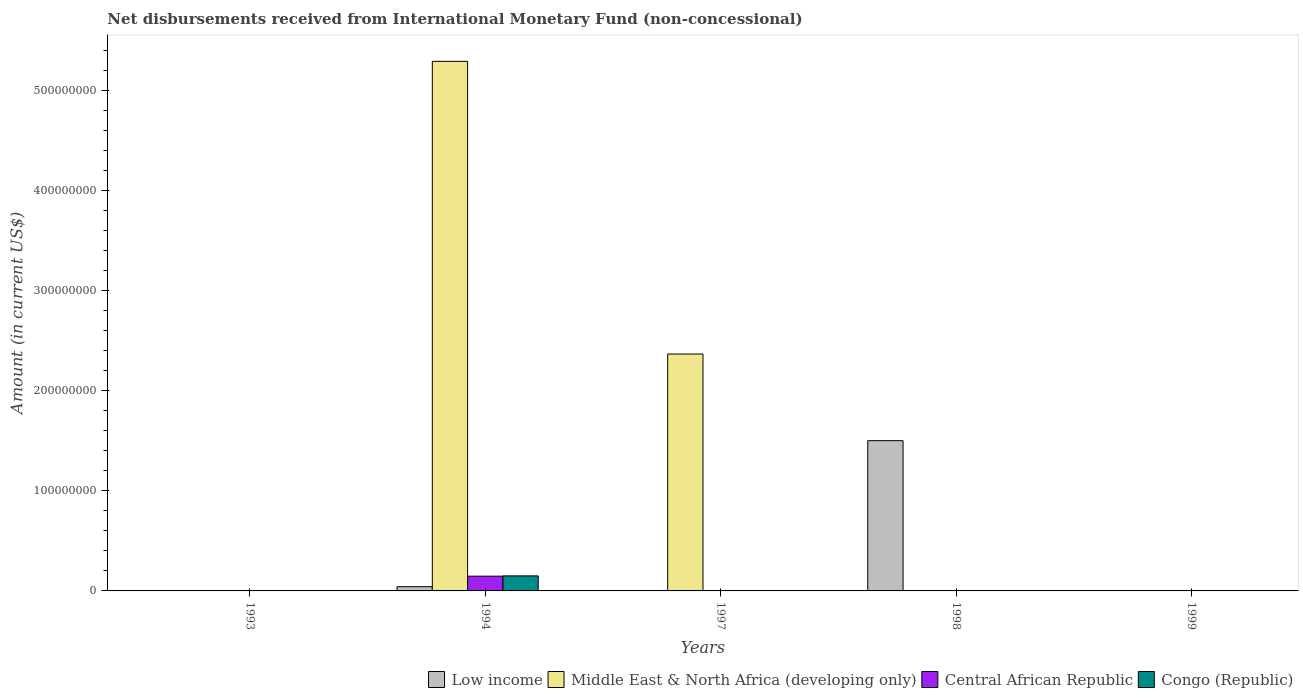How many different coloured bars are there?
Provide a short and direct response. 4. Are the number of bars on each tick of the X-axis equal?
Ensure brevity in your answer.  No. How many bars are there on the 4th tick from the right?
Keep it short and to the point. 4. What is the label of the 3rd group of bars from the left?
Make the answer very short. 1997. Across all years, what is the maximum amount of disbursements received from International Monetary Fund in Central African Republic?
Make the answer very short. 1.48e+07. Across all years, what is the minimum amount of disbursements received from International Monetary Fund in Central African Republic?
Ensure brevity in your answer.  0. What is the total amount of disbursements received from International Monetary Fund in Central African Republic in the graph?
Provide a succinct answer. 1.48e+07. What is the difference between the amount of disbursements received from International Monetary Fund in Middle East & North Africa (developing only) in 1994 and that in 1997?
Keep it short and to the point. 2.93e+08. What is the difference between the amount of disbursements received from International Monetary Fund in Congo (Republic) in 1999 and the amount of disbursements received from International Monetary Fund in Central African Republic in 1994?
Your response must be concise. -1.48e+07. What is the average amount of disbursements received from International Monetary Fund in Central African Republic per year?
Offer a terse response. 2.95e+06. In the year 1994, what is the difference between the amount of disbursements received from International Monetary Fund in Central African Republic and amount of disbursements received from International Monetary Fund in Congo (Republic)?
Offer a very short reply. -2.81e+05. In how many years, is the amount of disbursements received from International Monetary Fund in Central African Republic greater than 200000000 US$?
Your answer should be compact. 0. What is the difference between the highest and the lowest amount of disbursements received from International Monetary Fund in Low income?
Your answer should be very brief. 1.50e+08. Is it the case that in every year, the sum of the amount of disbursements received from International Monetary Fund in Low income and amount of disbursements received from International Monetary Fund in Congo (Republic) is greater than the sum of amount of disbursements received from International Monetary Fund in Central African Republic and amount of disbursements received from International Monetary Fund in Middle East & North Africa (developing only)?
Ensure brevity in your answer.  No. How many bars are there?
Ensure brevity in your answer.  6. Are all the bars in the graph horizontal?
Your answer should be very brief. No. How many years are there in the graph?
Ensure brevity in your answer.  5. What is the difference between two consecutive major ticks on the Y-axis?
Keep it short and to the point. 1.00e+08. Are the values on the major ticks of Y-axis written in scientific E-notation?
Keep it short and to the point. No. Does the graph contain any zero values?
Provide a succinct answer. Yes. Does the graph contain grids?
Make the answer very short. No. What is the title of the graph?
Keep it short and to the point. Net disbursements received from International Monetary Fund (non-concessional). What is the Amount (in current US$) of Low income in 1993?
Your answer should be compact. 0. What is the Amount (in current US$) of Central African Republic in 1993?
Provide a short and direct response. 0. What is the Amount (in current US$) of Low income in 1994?
Make the answer very short. 4.24e+06. What is the Amount (in current US$) in Middle East & North Africa (developing only) in 1994?
Your answer should be compact. 5.29e+08. What is the Amount (in current US$) of Central African Republic in 1994?
Your answer should be compact. 1.48e+07. What is the Amount (in current US$) in Congo (Republic) in 1994?
Offer a terse response. 1.50e+07. What is the Amount (in current US$) of Middle East & North Africa (developing only) in 1997?
Make the answer very short. 2.37e+08. What is the Amount (in current US$) in Central African Republic in 1997?
Your answer should be compact. 0. What is the Amount (in current US$) of Low income in 1998?
Provide a short and direct response. 1.50e+08. What is the Amount (in current US$) in Middle East & North Africa (developing only) in 1998?
Keep it short and to the point. 0. What is the Amount (in current US$) in Middle East & North Africa (developing only) in 1999?
Your answer should be compact. 0. What is the Amount (in current US$) of Central African Republic in 1999?
Your answer should be very brief. 0. What is the Amount (in current US$) of Congo (Republic) in 1999?
Provide a short and direct response. 0. Across all years, what is the maximum Amount (in current US$) of Low income?
Offer a very short reply. 1.50e+08. Across all years, what is the maximum Amount (in current US$) in Middle East & North Africa (developing only)?
Keep it short and to the point. 5.29e+08. Across all years, what is the maximum Amount (in current US$) of Central African Republic?
Keep it short and to the point. 1.48e+07. Across all years, what is the maximum Amount (in current US$) in Congo (Republic)?
Offer a very short reply. 1.50e+07. Across all years, what is the minimum Amount (in current US$) of Central African Republic?
Ensure brevity in your answer.  0. Across all years, what is the minimum Amount (in current US$) in Congo (Republic)?
Give a very brief answer. 0. What is the total Amount (in current US$) in Low income in the graph?
Offer a terse response. 1.54e+08. What is the total Amount (in current US$) in Middle East & North Africa (developing only) in the graph?
Your answer should be compact. 7.66e+08. What is the total Amount (in current US$) of Central African Republic in the graph?
Offer a very short reply. 1.48e+07. What is the total Amount (in current US$) in Congo (Republic) in the graph?
Your answer should be compact. 1.50e+07. What is the difference between the Amount (in current US$) of Middle East & North Africa (developing only) in 1994 and that in 1997?
Your answer should be compact. 2.93e+08. What is the difference between the Amount (in current US$) in Low income in 1994 and that in 1998?
Your response must be concise. -1.46e+08. What is the difference between the Amount (in current US$) in Low income in 1994 and the Amount (in current US$) in Middle East & North Africa (developing only) in 1997?
Give a very brief answer. -2.33e+08. What is the average Amount (in current US$) of Low income per year?
Keep it short and to the point. 3.09e+07. What is the average Amount (in current US$) in Middle East & North Africa (developing only) per year?
Ensure brevity in your answer.  1.53e+08. What is the average Amount (in current US$) of Central African Republic per year?
Your response must be concise. 2.95e+06. What is the average Amount (in current US$) in Congo (Republic) per year?
Your response must be concise. 3.01e+06. In the year 1994, what is the difference between the Amount (in current US$) in Low income and Amount (in current US$) in Middle East & North Africa (developing only)?
Your answer should be compact. -5.25e+08. In the year 1994, what is the difference between the Amount (in current US$) of Low income and Amount (in current US$) of Central African Republic?
Keep it short and to the point. -1.05e+07. In the year 1994, what is the difference between the Amount (in current US$) of Low income and Amount (in current US$) of Congo (Republic)?
Offer a terse response. -1.08e+07. In the year 1994, what is the difference between the Amount (in current US$) in Middle East & North Africa (developing only) and Amount (in current US$) in Central African Republic?
Keep it short and to the point. 5.15e+08. In the year 1994, what is the difference between the Amount (in current US$) of Middle East & North Africa (developing only) and Amount (in current US$) of Congo (Republic)?
Offer a very short reply. 5.14e+08. In the year 1994, what is the difference between the Amount (in current US$) in Central African Republic and Amount (in current US$) in Congo (Republic)?
Provide a succinct answer. -2.81e+05. What is the ratio of the Amount (in current US$) in Middle East & North Africa (developing only) in 1994 to that in 1997?
Your answer should be compact. 2.24. What is the ratio of the Amount (in current US$) of Low income in 1994 to that in 1998?
Provide a succinct answer. 0.03. What is the difference between the highest and the lowest Amount (in current US$) in Low income?
Keep it short and to the point. 1.50e+08. What is the difference between the highest and the lowest Amount (in current US$) in Middle East & North Africa (developing only)?
Make the answer very short. 5.29e+08. What is the difference between the highest and the lowest Amount (in current US$) of Central African Republic?
Ensure brevity in your answer.  1.48e+07. What is the difference between the highest and the lowest Amount (in current US$) of Congo (Republic)?
Make the answer very short. 1.50e+07. 